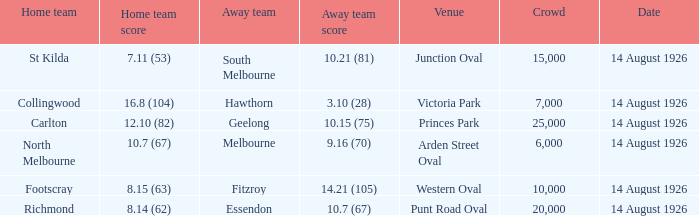How many individuals were in the crowd at victoria park? 7000.0. 